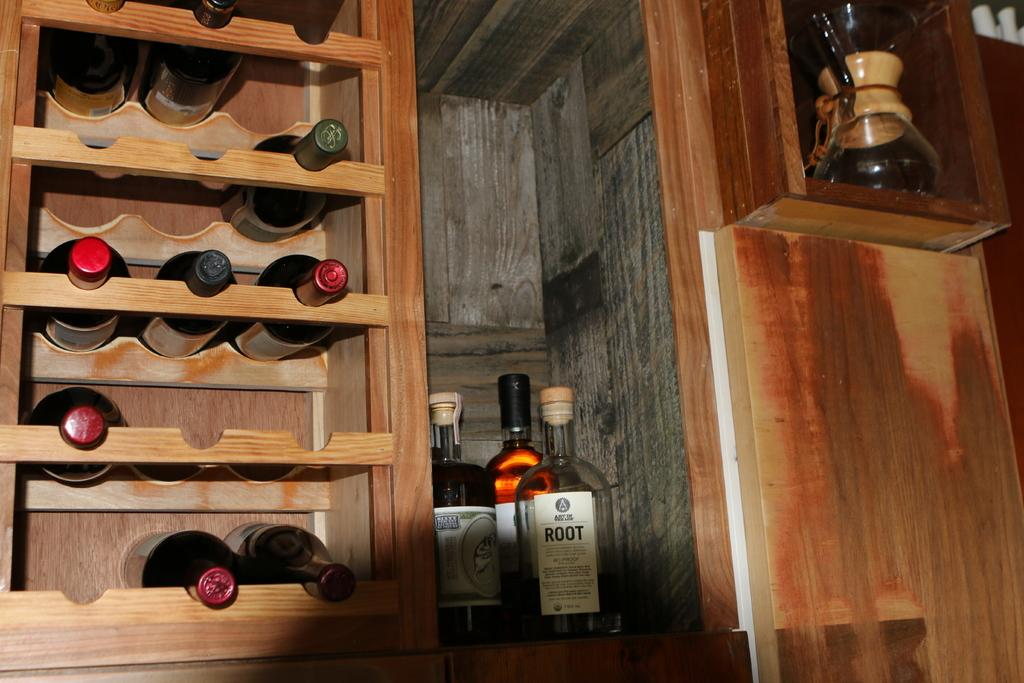What type of surface are the bottles placed on? The bottles are placed on a wooden surface. Where else can bottles be found in the image? The bottles are also in wooden shelves. What color bead is hanging from the doctor's stethoscope in the image? There is no doctor or bead present in the image; it only features bottles on a wooden surface and in wooden shelves. 